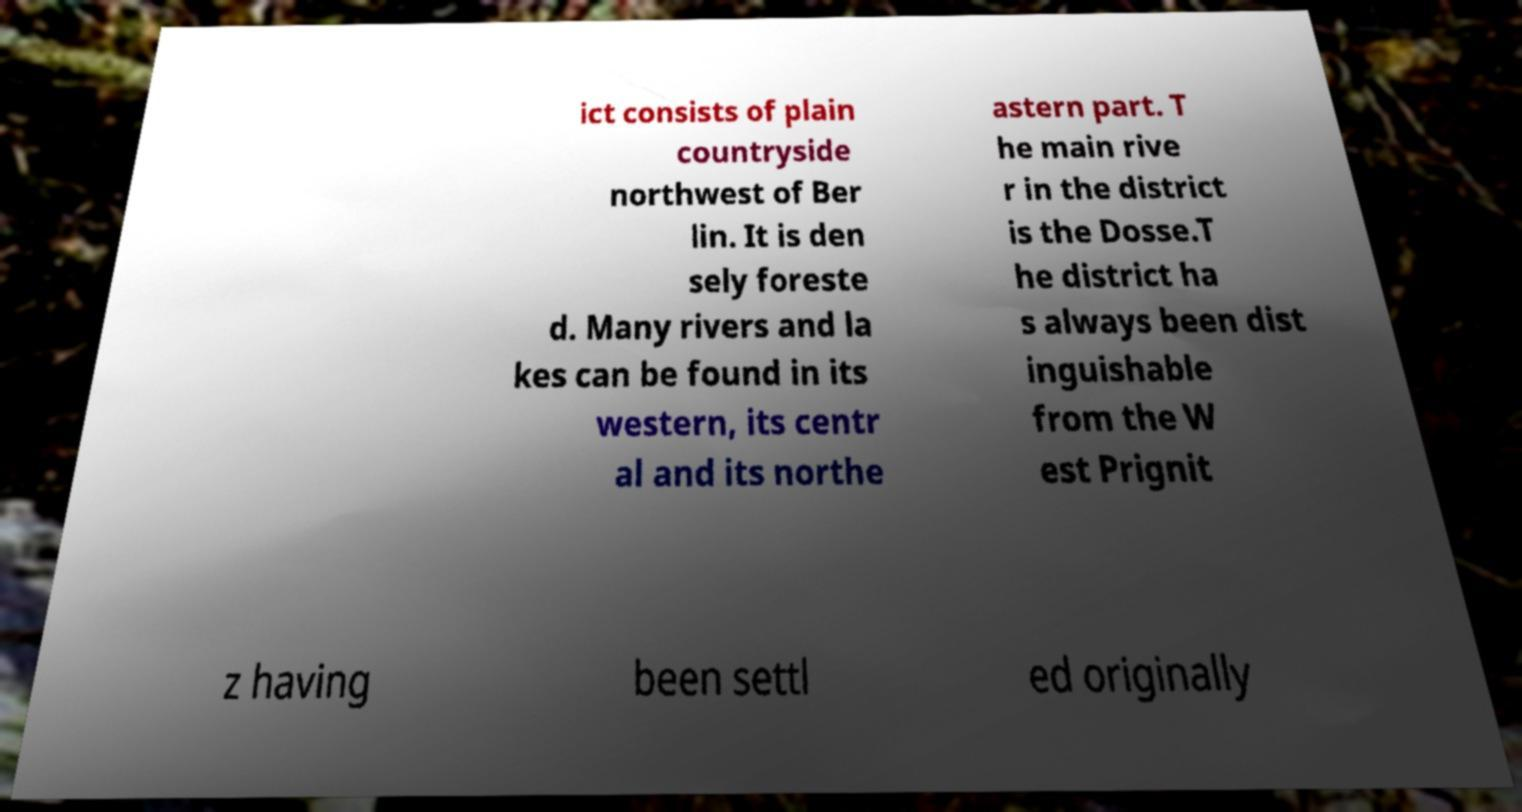What messages or text are displayed in this image? I need them in a readable, typed format. ict consists of plain countryside northwest of Ber lin. It is den sely foreste d. Many rivers and la kes can be found in its western, its centr al and its northe astern part. T he main rive r in the district is the Dosse.T he district ha s always been dist inguishable from the W est Prignit z having been settl ed originally 